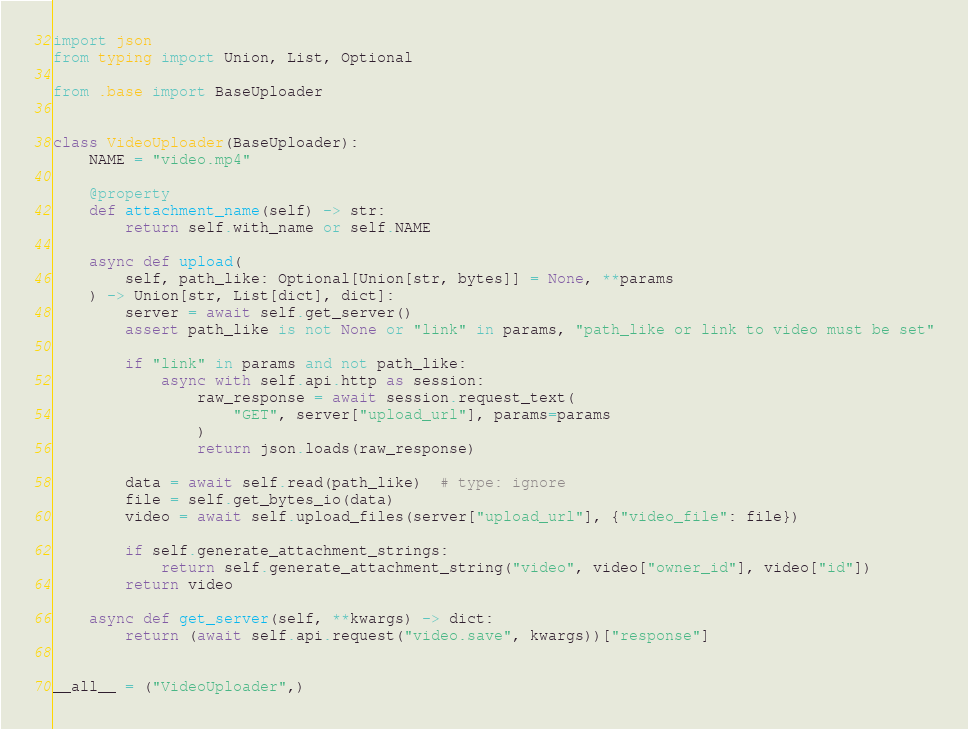Convert code to text. <code><loc_0><loc_0><loc_500><loc_500><_Python_>import json
from typing import Union, List, Optional

from .base import BaseUploader


class VideoUploader(BaseUploader):
    NAME = "video.mp4"

    @property
    def attachment_name(self) -> str:
        return self.with_name or self.NAME

    async def upload(
        self, path_like: Optional[Union[str, bytes]] = None, **params
    ) -> Union[str, List[dict], dict]:
        server = await self.get_server()
        assert path_like is not None or "link" in params, "path_like or link to video must be set"

        if "link" in params and not path_like:
            async with self.api.http as session:
                raw_response = await session.request_text(
                    "GET", server["upload_url"], params=params
                )
                return json.loads(raw_response)

        data = await self.read(path_like)  # type: ignore
        file = self.get_bytes_io(data)
        video = await self.upload_files(server["upload_url"], {"video_file": file})

        if self.generate_attachment_strings:
            return self.generate_attachment_string("video", video["owner_id"], video["id"])
        return video

    async def get_server(self, **kwargs) -> dict:
        return (await self.api.request("video.save", kwargs))["response"]


__all__ = ("VideoUploader",)
</code> 